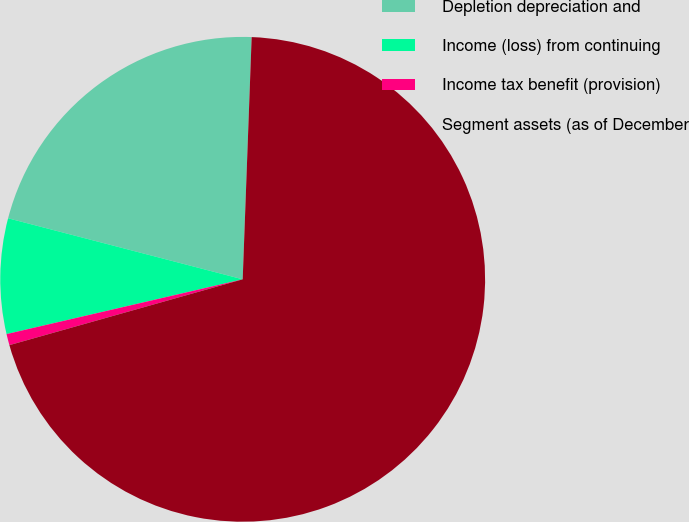<chart> <loc_0><loc_0><loc_500><loc_500><pie_chart><fcel>Depletion depreciation and<fcel>Income (loss) from continuing<fcel>Income tax benefit (provision)<fcel>Segment assets (as of December<nl><fcel>21.54%<fcel>7.68%<fcel>0.75%<fcel>70.04%<nl></chart> 